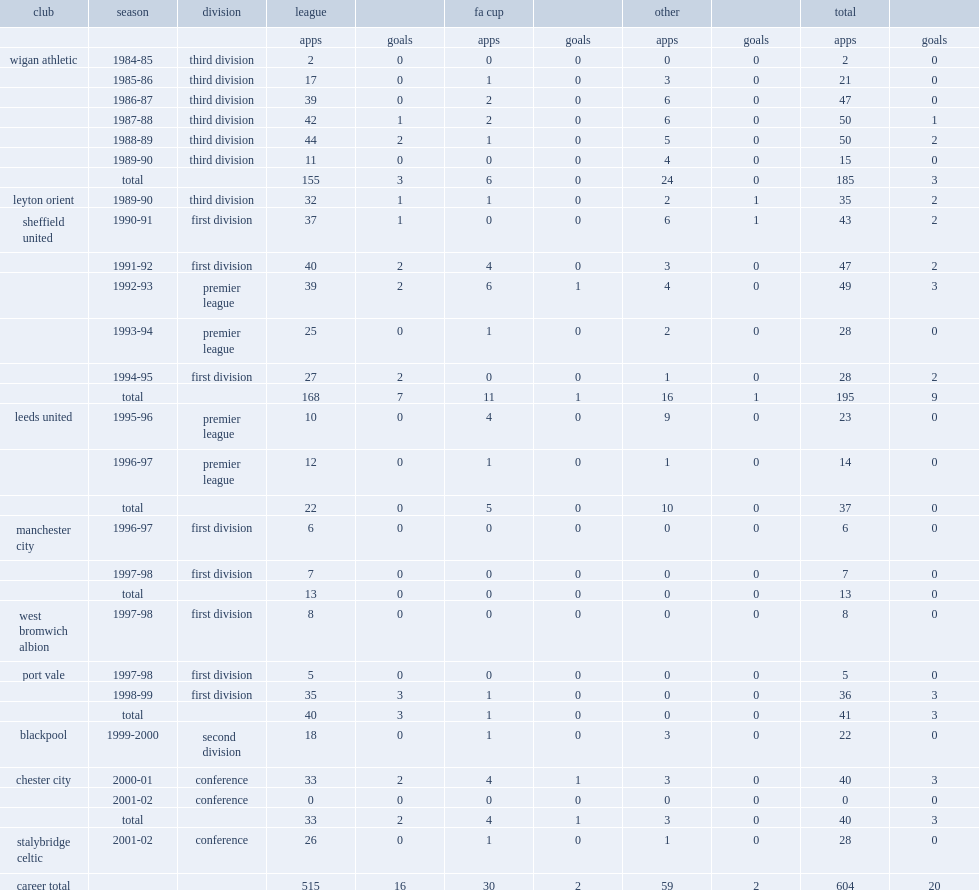How many games did paul beesley play before joining leyton orient in 1989? 185.0. 